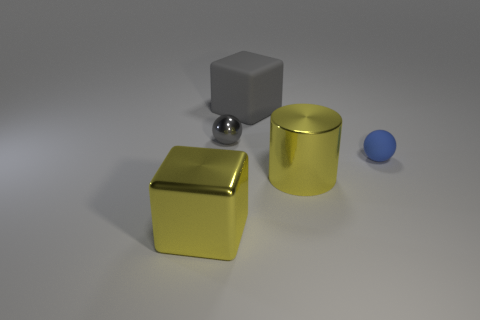Does the big cylinder have the same color as the shiny block?
Your answer should be very brief. Yes. There is a big cylinder that is on the right side of the large rubber thing; is it the same color as the big metallic block?
Your response must be concise. Yes. What shape is the metallic thing that is the same color as the large metallic block?
Provide a short and direct response. Cylinder. Are there any objects that have the same color as the matte cube?
Your response must be concise. Yes. There is a matte thing left of the tiny blue rubber thing; is it the same color as the sphere that is behind the matte sphere?
Your answer should be compact. Yes. What size is the block that is the same color as the cylinder?
Make the answer very short. Large. What color is the large block that is to the right of the large yellow metal cube?
Provide a succinct answer. Gray. Are the cube in front of the blue thing and the blue ball made of the same material?
Keep it short and to the point. No. What number of tiny balls are on the left side of the rubber cube and in front of the gray shiny object?
Your answer should be compact. 0. What color is the cube in front of the small object that is right of the small object that is behind the small matte ball?
Offer a very short reply. Yellow. 